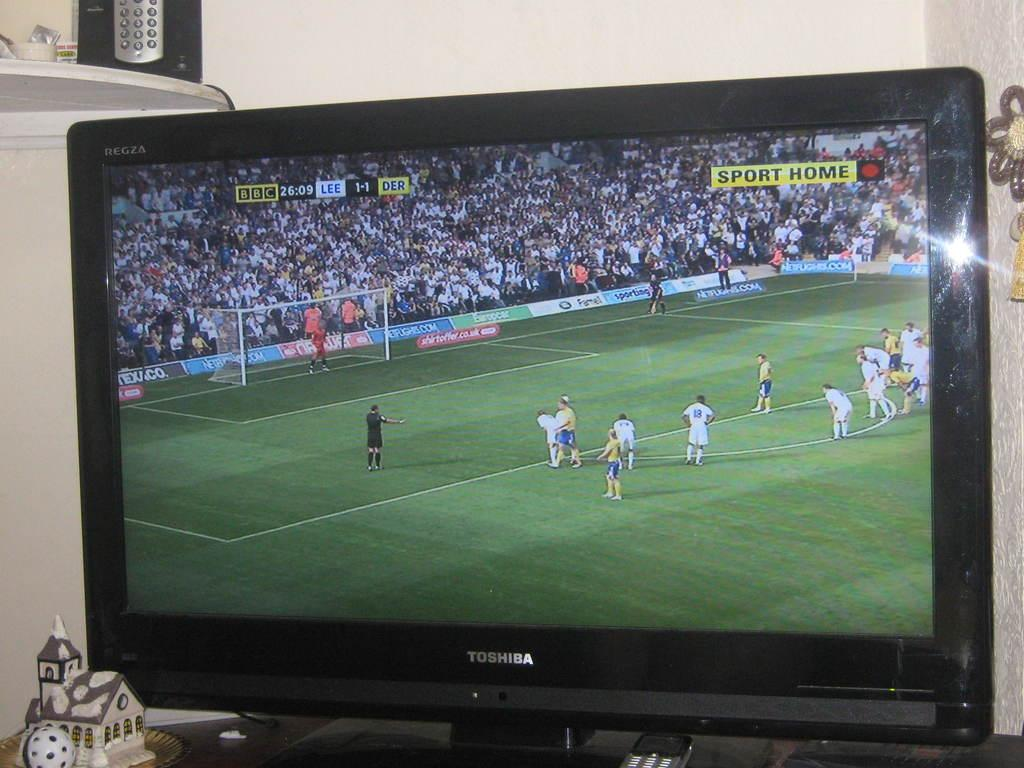<image>
Describe the image concisely. A football match being shown on a tv screen made by Toshiba. 